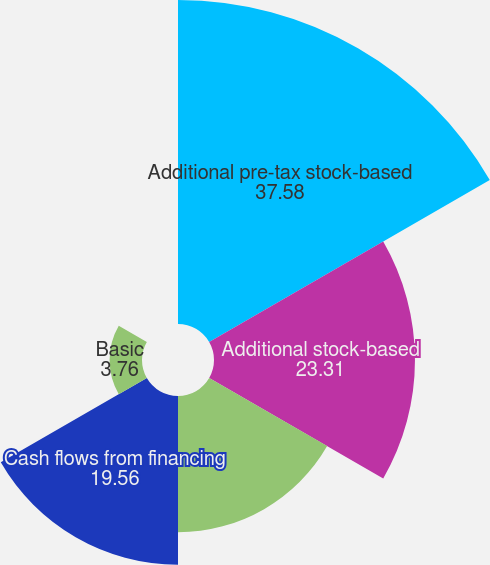Convert chart. <chart><loc_0><loc_0><loc_500><loc_500><pie_chart><fcel>Additional pre-tax stock-based<fcel>Additional stock-based<fcel>Cash flows from operations<fcel>Cash flows from financing<fcel>Basic<fcel>Diluted<nl><fcel>37.58%<fcel>23.31%<fcel>15.8%<fcel>19.56%<fcel>3.76%<fcel>0.0%<nl></chart> 